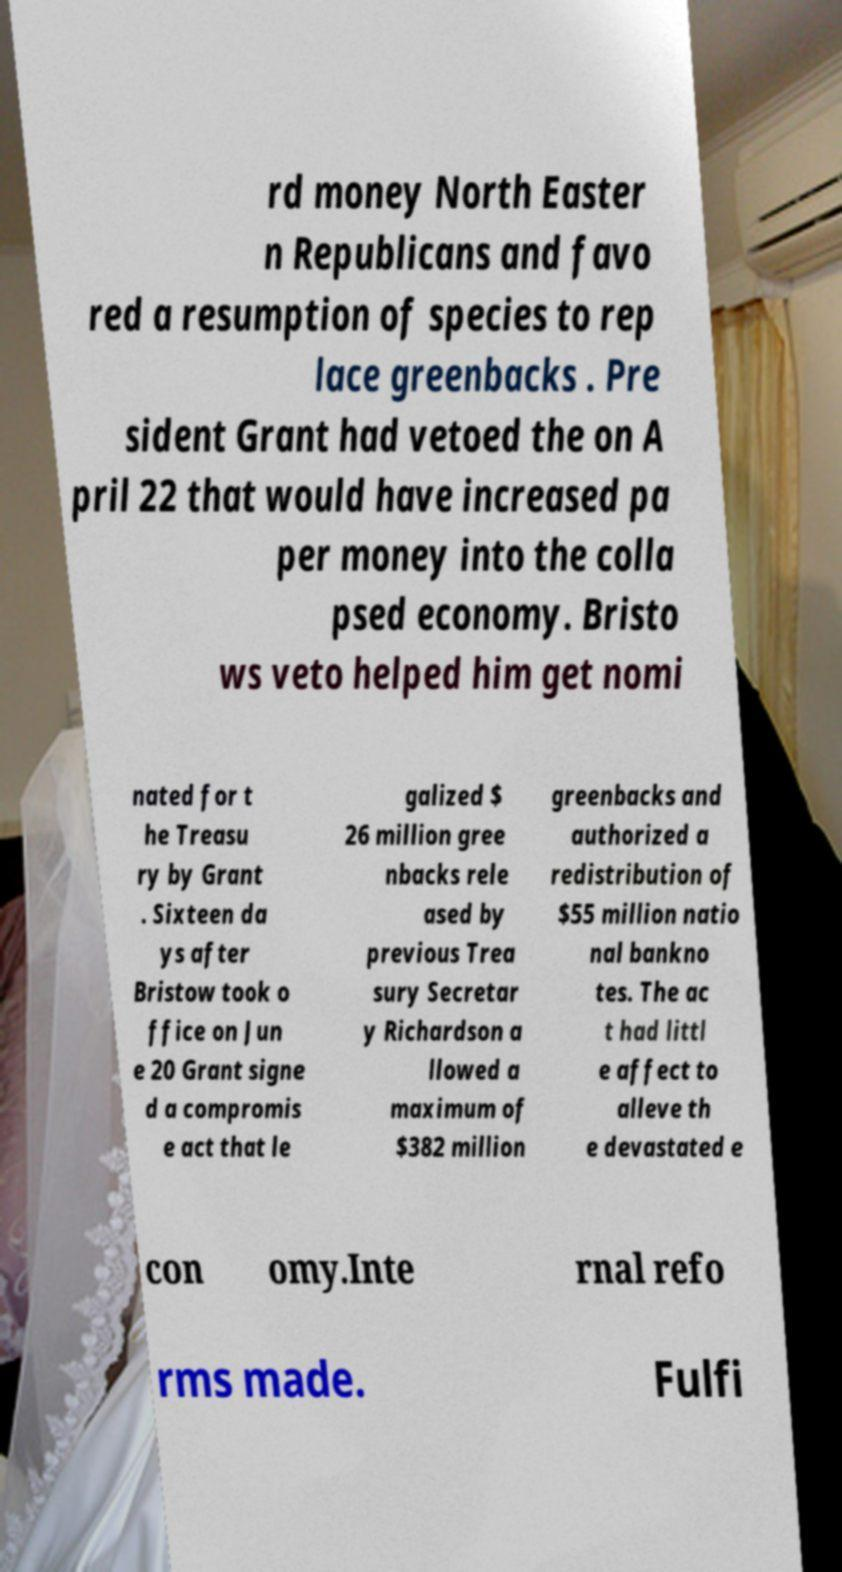Can you read and provide the text displayed in the image?This photo seems to have some interesting text. Can you extract and type it out for me? rd money North Easter n Republicans and favo red a resumption of species to rep lace greenbacks . Pre sident Grant had vetoed the on A pril 22 that would have increased pa per money into the colla psed economy. Bristo ws veto helped him get nomi nated for t he Treasu ry by Grant . Sixteen da ys after Bristow took o ffice on Jun e 20 Grant signe d a compromis e act that le galized $ 26 million gree nbacks rele ased by previous Trea sury Secretar y Richardson a llowed a maximum of $382 million greenbacks and authorized a redistribution of $55 million natio nal bankno tes. The ac t had littl e affect to alleve th e devastated e con omy.Inte rnal refo rms made. Fulfi 